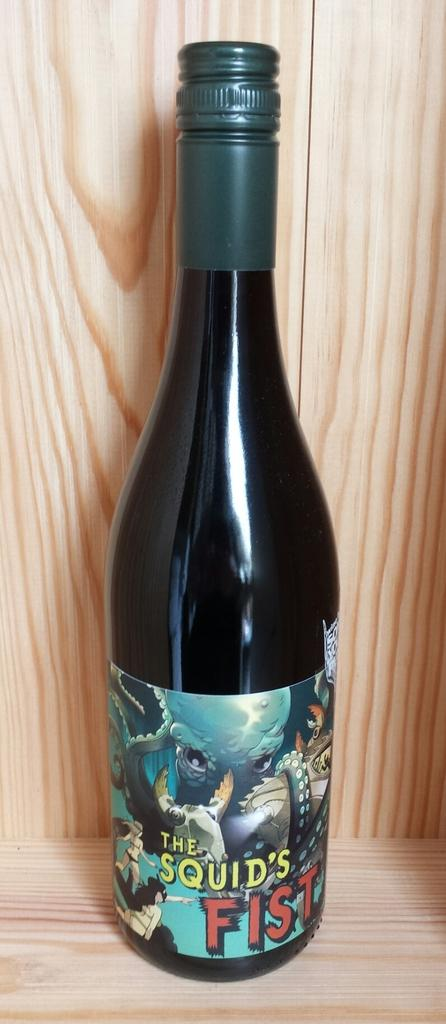<image>
Share a concise interpretation of the image provided. a bottle of alcohol that is labeled 'the squid's fist' 